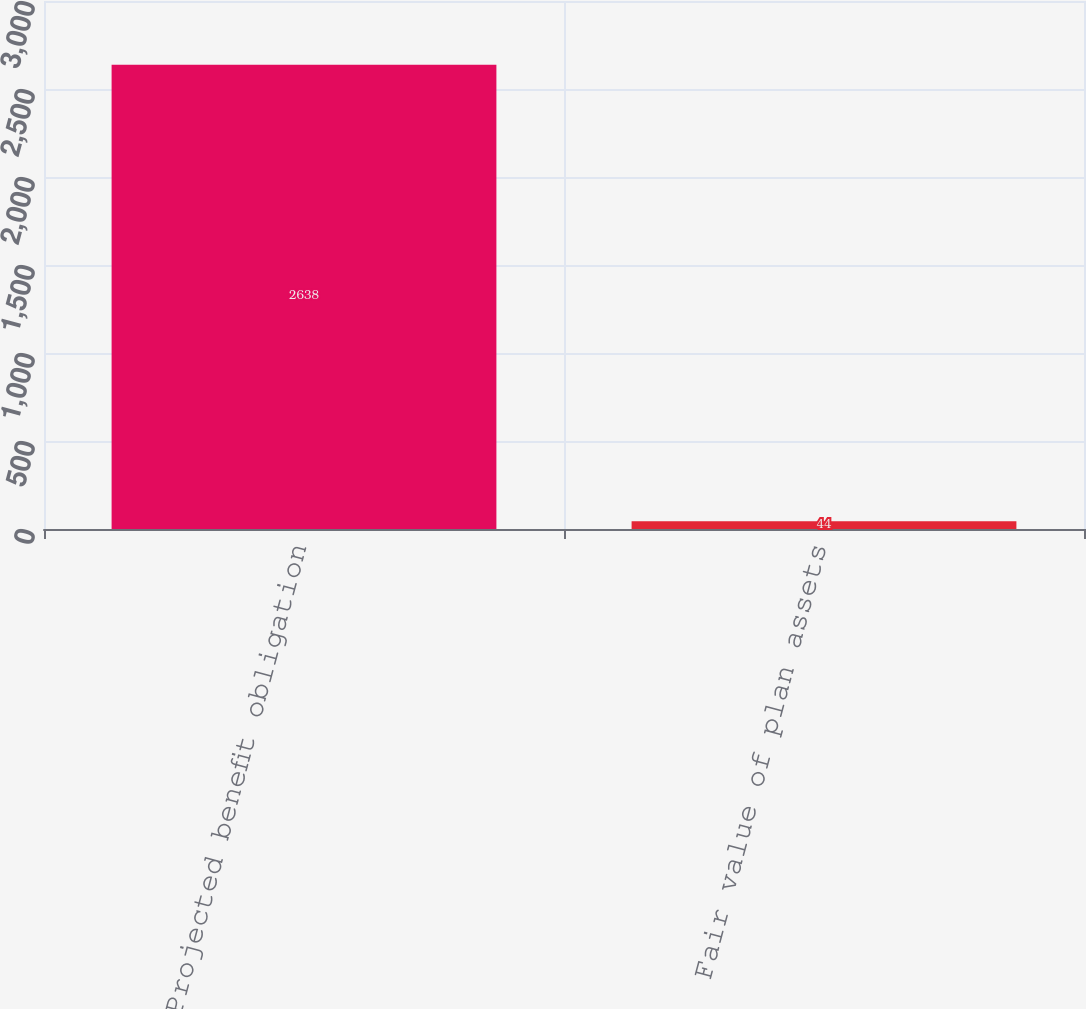<chart> <loc_0><loc_0><loc_500><loc_500><bar_chart><fcel>Projected benefit obligation<fcel>Fair value of plan assets<nl><fcel>2638<fcel>44<nl></chart> 